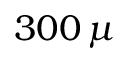<formula> <loc_0><loc_0><loc_500><loc_500>3 0 0 \, \mu</formula> 